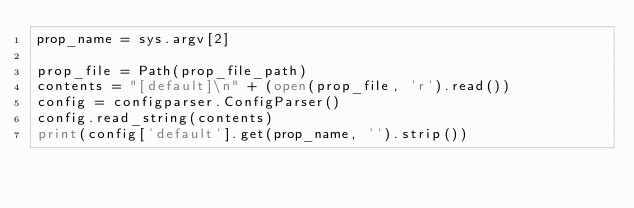Convert code to text. <code><loc_0><loc_0><loc_500><loc_500><_Python_>prop_name = sys.argv[2]

prop_file = Path(prop_file_path)
contents = "[default]\n" + (open(prop_file, 'r').read())
config = configparser.ConfigParser()
config.read_string(contents)
print(config['default'].get(prop_name, '').strip())
</code> 